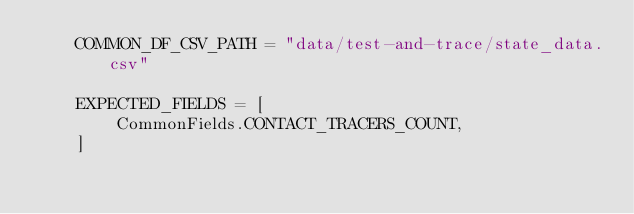Convert code to text. <code><loc_0><loc_0><loc_500><loc_500><_Python_>    COMMON_DF_CSV_PATH = "data/test-and-trace/state_data.csv"

    EXPECTED_FIELDS = [
        CommonFields.CONTACT_TRACERS_COUNT,
    ]
</code> 